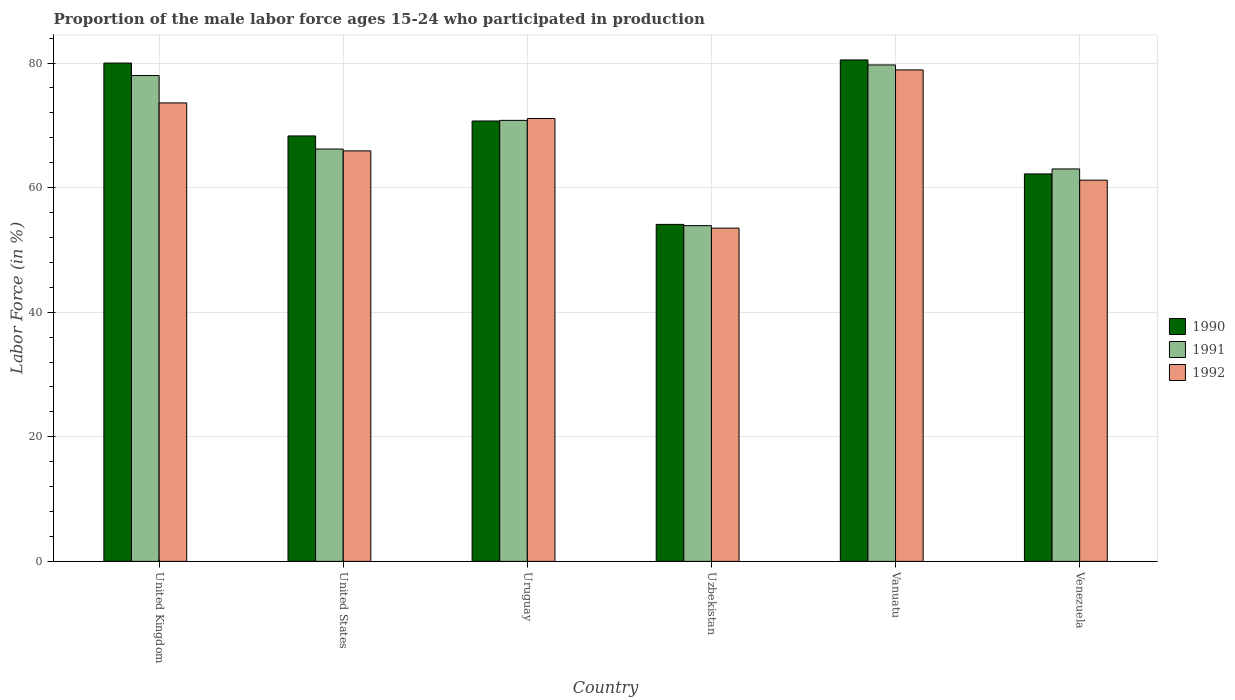How many groups of bars are there?
Ensure brevity in your answer.  6. Are the number of bars per tick equal to the number of legend labels?
Keep it short and to the point. Yes. How many bars are there on the 4th tick from the left?
Offer a terse response. 3. What is the label of the 2nd group of bars from the left?
Provide a short and direct response. United States. What is the proportion of the male labor force who participated in production in 1992 in Vanuatu?
Give a very brief answer. 78.9. Across all countries, what is the maximum proportion of the male labor force who participated in production in 1990?
Your response must be concise. 80.5. Across all countries, what is the minimum proportion of the male labor force who participated in production in 1992?
Offer a very short reply. 53.5. In which country was the proportion of the male labor force who participated in production in 1992 maximum?
Make the answer very short. Vanuatu. In which country was the proportion of the male labor force who participated in production in 1992 minimum?
Your response must be concise. Uzbekistan. What is the total proportion of the male labor force who participated in production in 1991 in the graph?
Provide a succinct answer. 411.6. What is the difference between the proportion of the male labor force who participated in production in 1991 in Uruguay and that in Venezuela?
Ensure brevity in your answer.  7.8. What is the difference between the proportion of the male labor force who participated in production in 1991 in United States and the proportion of the male labor force who participated in production in 1992 in United Kingdom?
Keep it short and to the point. -7.4. What is the average proportion of the male labor force who participated in production in 1991 per country?
Give a very brief answer. 68.6. What is the difference between the proportion of the male labor force who participated in production of/in 1992 and proportion of the male labor force who participated in production of/in 1990 in Uruguay?
Provide a short and direct response. 0.4. In how many countries, is the proportion of the male labor force who participated in production in 1992 greater than 64 %?
Ensure brevity in your answer.  4. What is the ratio of the proportion of the male labor force who participated in production in 1992 in United Kingdom to that in Venezuela?
Ensure brevity in your answer.  1.2. Is the proportion of the male labor force who participated in production in 1991 in Vanuatu less than that in Venezuela?
Keep it short and to the point. No. Is the difference between the proportion of the male labor force who participated in production in 1992 in United States and Uruguay greater than the difference between the proportion of the male labor force who participated in production in 1990 in United States and Uruguay?
Offer a terse response. No. What is the difference between the highest and the second highest proportion of the male labor force who participated in production in 1992?
Ensure brevity in your answer.  -5.3. What is the difference between the highest and the lowest proportion of the male labor force who participated in production in 1992?
Provide a succinct answer. 25.4. In how many countries, is the proportion of the male labor force who participated in production in 1992 greater than the average proportion of the male labor force who participated in production in 1992 taken over all countries?
Your response must be concise. 3. Is it the case that in every country, the sum of the proportion of the male labor force who participated in production in 1992 and proportion of the male labor force who participated in production in 1990 is greater than the proportion of the male labor force who participated in production in 1991?
Provide a succinct answer. Yes. Are all the bars in the graph horizontal?
Give a very brief answer. No. How many countries are there in the graph?
Your answer should be compact. 6. Are the values on the major ticks of Y-axis written in scientific E-notation?
Provide a succinct answer. No. Does the graph contain any zero values?
Your response must be concise. No. How many legend labels are there?
Your response must be concise. 3. What is the title of the graph?
Provide a short and direct response. Proportion of the male labor force ages 15-24 who participated in production. What is the Labor Force (in %) in 1990 in United Kingdom?
Offer a terse response. 80. What is the Labor Force (in %) of 1992 in United Kingdom?
Provide a succinct answer. 73.6. What is the Labor Force (in %) in 1990 in United States?
Offer a terse response. 68.3. What is the Labor Force (in %) of 1991 in United States?
Your response must be concise. 66.2. What is the Labor Force (in %) in 1992 in United States?
Provide a succinct answer. 65.9. What is the Labor Force (in %) of 1990 in Uruguay?
Your answer should be very brief. 70.7. What is the Labor Force (in %) in 1991 in Uruguay?
Your answer should be compact. 70.8. What is the Labor Force (in %) of 1992 in Uruguay?
Provide a short and direct response. 71.1. What is the Labor Force (in %) of 1990 in Uzbekistan?
Your response must be concise. 54.1. What is the Labor Force (in %) in 1991 in Uzbekistan?
Provide a short and direct response. 53.9. What is the Labor Force (in %) of 1992 in Uzbekistan?
Give a very brief answer. 53.5. What is the Labor Force (in %) in 1990 in Vanuatu?
Offer a very short reply. 80.5. What is the Labor Force (in %) in 1991 in Vanuatu?
Your response must be concise. 79.7. What is the Labor Force (in %) in 1992 in Vanuatu?
Your response must be concise. 78.9. What is the Labor Force (in %) of 1990 in Venezuela?
Provide a succinct answer. 62.2. What is the Labor Force (in %) of 1992 in Venezuela?
Give a very brief answer. 61.2. Across all countries, what is the maximum Labor Force (in %) in 1990?
Make the answer very short. 80.5. Across all countries, what is the maximum Labor Force (in %) of 1991?
Make the answer very short. 79.7. Across all countries, what is the maximum Labor Force (in %) in 1992?
Give a very brief answer. 78.9. Across all countries, what is the minimum Labor Force (in %) of 1990?
Offer a very short reply. 54.1. Across all countries, what is the minimum Labor Force (in %) in 1991?
Give a very brief answer. 53.9. Across all countries, what is the minimum Labor Force (in %) of 1992?
Your answer should be compact. 53.5. What is the total Labor Force (in %) of 1990 in the graph?
Give a very brief answer. 415.8. What is the total Labor Force (in %) of 1991 in the graph?
Your response must be concise. 411.6. What is the total Labor Force (in %) of 1992 in the graph?
Keep it short and to the point. 404.2. What is the difference between the Labor Force (in %) of 1992 in United Kingdom and that in United States?
Give a very brief answer. 7.7. What is the difference between the Labor Force (in %) in 1991 in United Kingdom and that in Uruguay?
Your answer should be compact. 7.2. What is the difference between the Labor Force (in %) of 1992 in United Kingdom and that in Uruguay?
Your response must be concise. 2.5. What is the difference between the Labor Force (in %) in 1990 in United Kingdom and that in Uzbekistan?
Make the answer very short. 25.9. What is the difference between the Labor Force (in %) of 1991 in United Kingdom and that in Uzbekistan?
Offer a terse response. 24.1. What is the difference between the Labor Force (in %) of 1992 in United Kingdom and that in Uzbekistan?
Offer a terse response. 20.1. What is the difference between the Labor Force (in %) in 1990 in United Kingdom and that in Vanuatu?
Your response must be concise. -0.5. What is the difference between the Labor Force (in %) of 1992 in United Kingdom and that in Vanuatu?
Offer a terse response. -5.3. What is the difference between the Labor Force (in %) of 1990 in United States and that in Uruguay?
Provide a short and direct response. -2.4. What is the difference between the Labor Force (in %) of 1991 in United States and that in Uruguay?
Your response must be concise. -4.6. What is the difference between the Labor Force (in %) of 1992 in United States and that in Uruguay?
Provide a succinct answer. -5.2. What is the difference between the Labor Force (in %) of 1991 in United States and that in Uzbekistan?
Give a very brief answer. 12.3. What is the difference between the Labor Force (in %) of 1992 in United States and that in Uzbekistan?
Keep it short and to the point. 12.4. What is the difference between the Labor Force (in %) in 1990 in United States and that in Vanuatu?
Give a very brief answer. -12.2. What is the difference between the Labor Force (in %) in 1991 in United States and that in Vanuatu?
Ensure brevity in your answer.  -13.5. What is the difference between the Labor Force (in %) of 1990 in United States and that in Venezuela?
Provide a succinct answer. 6.1. What is the difference between the Labor Force (in %) in 1991 in United States and that in Venezuela?
Give a very brief answer. 3.2. What is the difference between the Labor Force (in %) of 1992 in United States and that in Venezuela?
Offer a very short reply. 4.7. What is the difference between the Labor Force (in %) of 1990 in Uruguay and that in Uzbekistan?
Provide a short and direct response. 16.6. What is the difference between the Labor Force (in %) of 1991 in Uruguay and that in Uzbekistan?
Ensure brevity in your answer.  16.9. What is the difference between the Labor Force (in %) in 1991 in Uruguay and that in Venezuela?
Provide a short and direct response. 7.8. What is the difference between the Labor Force (in %) in 1992 in Uruguay and that in Venezuela?
Your answer should be very brief. 9.9. What is the difference between the Labor Force (in %) in 1990 in Uzbekistan and that in Vanuatu?
Your answer should be compact. -26.4. What is the difference between the Labor Force (in %) of 1991 in Uzbekistan and that in Vanuatu?
Offer a terse response. -25.8. What is the difference between the Labor Force (in %) of 1992 in Uzbekistan and that in Vanuatu?
Your answer should be compact. -25.4. What is the difference between the Labor Force (in %) in 1990 in Uzbekistan and that in Venezuela?
Keep it short and to the point. -8.1. What is the difference between the Labor Force (in %) in 1991 in Uzbekistan and that in Venezuela?
Your answer should be compact. -9.1. What is the difference between the Labor Force (in %) in 1990 in Vanuatu and that in Venezuela?
Your answer should be compact. 18.3. What is the difference between the Labor Force (in %) of 1990 in United Kingdom and the Labor Force (in %) of 1991 in United States?
Offer a very short reply. 13.8. What is the difference between the Labor Force (in %) of 1990 in United Kingdom and the Labor Force (in %) of 1992 in Uruguay?
Give a very brief answer. 8.9. What is the difference between the Labor Force (in %) in 1990 in United Kingdom and the Labor Force (in %) in 1991 in Uzbekistan?
Give a very brief answer. 26.1. What is the difference between the Labor Force (in %) in 1990 in United Kingdom and the Labor Force (in %) in 1992 in Uzbekistan?
Keep it short and to the point. 26.5. What is the difference between the Labor Force (in %) of 1990 in United Kingdom and the Labor Force (in %) of 1992 in Vanuatu?
Your answer should be compact. 1.1. What is the difference between the Labor Force (in %) in 1991 in United Kingdom and the Labor Force (in %) in 1992 in Vanuatu?
Ensure brevity in your answer.  -0.9. What is the difference between the Labor Force (in %) of 1991 in United Kingdom and the Labor Force (in %) of 1992 in Venezuela?
Make the answer very short. 16.8. What is the difference between the Labor Force (in %) of 1990 in United States and the Labor Force (in %) of 1991 in Uruguay?
Keep it short and to the point. -2.5. What is the difference between the Labor Force (in %) in 1990 in United States and the Labor Force (in %) in 1992 in Uzbekistan?
Your answer should be compact. 14.8. What is the difference between the Labor Force (in %) of 1990 in United States and the Labor Force (in %) of 1992 in Venezuela?
Your answer should be compact. 7.1. What is the difference between the Labor Force (in %) of 1991 in United States and the Labor Force (in %) of 1992 in Venezuela?
Give a very brief answer. 5. What is the difference between the Labor Force (in %) in 1991 in Uruguay and the Labor Force (in %) in 1992 in Uzbekistan?
Make the answer very short. 17.3. What is the difference between the Labor Force (in %) of 1991 in Uruguay and the Labor Force (in %) of 1992 in Vanuatu?
Offer a terse response. -8.1. What is the difference between the Labor Force (in %) in 1990 in Uruguay and the Labor Force (in %) in 1991 in Venezuela?
Give a very brief answer. 7.7. What is the difference between the Labor Force (in %) of 1990 in Uzbekistan and the Labor Force (in %) of 1991 in Vanuatu?
Provide a short and direct response. -25.6. What is the difference between the Labor Force (in %) in 1990 in Uzbekistan and the Labor Force (in %) in 1992 in Vanuatu?
Your answer should be very brief. -24.8. What is the difference between the Labor Force (in %) in 1990 in Uzbekistan and the Labor Force (in %) in 1992 in Venezuela?
Provide a short and direct response. -7.1. What is the difference between the Labor Force (in %) in 1991 in Uzbekistan and the Labor Force (in %) in 1992 in Venezuela?
Your answer should be compact. -7.3. What is the difference between the Labor Force (in %) of 1990 in Vanuatu and the Labor Force (in %) of 1992 in Venezuela?
Your answer should be very brief. 19.3. What is the difference between the Labor Force (in %) in 1991 in Vanuatu and the Labor Force (in %) in 1992 in Venezuela?
Your answer should be very brief. 18.5. What is the average Labor Force (in %) of 1990 per country?
Keep it short and to the point. 69.3. What is the average Labor Force (in %) of 1991 per country?
Your answer should be compact. 68.6. What is the average Labor Force (in %) of 1992 per country?
Ensure brevity in your answer.  67.37. What is the difference between the Labor Force (in %) in 1990 and Labor Force (in %) in 1991 in United Kingdom?
Give a very brief answer. 2. What is the difference between the Labor Force (in %) of 1990 and Labor Force (in %) of 1991 in United States?
Offer a terse response. 2.1. What is the difference between the Labor Force (in %) of 1990 and Labor Force (in %) of 1991 in Uruguay?
Make the answer very short. -0.1. What is the difference between the Labor Force (in %) in 1990 and Labor Force (in %) in 1992 in Uruguay?
Make the answer very short. -0.4. What is the difference between the Labor Force (in %) in 1991 and Labor Force (in %) in 1992 in Uzbekistan?
Give a very brief answer. 0.4. What is the difference between the Labor Force (in %) in 1990 and Labor Force (in %) in 1991 in Vanuatu?
Make the answer very short. 0.8. What is the difference between the Labor Force (in %) in 1991 and Labor Force (in %) in 1992 in Vanuatu?
Provide a succinct answer. 0.8. What is the difference between the Labor Force (in %) of 1990 and Labor Force (in %) of 1992 in Venezuela?
Provide a short and direct response. 1. What is the difference between the Labor Force (in %) of 1991 and Labor Force (in %) of 1992 in Venezuela?
Offer a very short reply. 1.8. What is the ratio of the Labor Force (in %) in 1990 in United Kingdom to that in United States?
Keep it short and to the point. 1.17. What is the ratio of the Labor Force (in %) of 1991 in United Kingdom to that in United States?
Provide a succinct answer. 1.18. What is the ratio of the Labor Force (in %) in 1992 in United Kingdom to that in United States?
Provide a succinct answer. 1.12. What is the ratio of the Labor Force (in %) in 1990 in United Kingdom to that in Uruguay?
Your response must be concise. 1.13. What is the ratio of the Labor Force (in %) in 1991 in United Kingdom to that in Uruguay?
Provide a short and direct response. 1.1. What is the ratio of the Labor Force (in %) in 1992 in United Kingdom to that in Uruguay?
Ensure brevity in your answer.  1.04. What is the ratio of the Labor Force (in %) of 1990 in United Kingdom to that in Uzbekistan?
Your answer should be compact. 1.48. What is the ratio of the Labor Force (in %) of 1991 in United Kingdom to that in Uzbekistan?
Provide a short and direct response. 1.45. What is the ratio of the Labor Force (in %) of 1992 in United Kingdom to that in Uzbekistan?
Ensure brevity in your answer.  1.38. What is the ratio of the Labor Force (in %) in 1991 in United Kingdom to that in Vanuatu?
Your answer should be compact. 0.98. What is the ratio of the Labor Force (in %) of 1992 in United Kingdom to that in Vanuatu?
Make the answer very short. 0.93. What is the ratio of the Labor Force (in %) in 1990 in United Kingdom to that in Venezuela?
Provide a short and direct response. 1.29. What is the ratio of the Labor Force (in %) in 1991 in United Kingdom to that in Venezuela?
Make the answer very short. 1.24. What is the ratio of the Labor Force (in %) in 1992 in United Kingdom to that in Venezuela?
Your answer should be compact. 1.2. What is the ratio of the Labor Force (in %) of 1990 in United States to that in Uruguay?
Ensure brevity in your answer.  0.97. What is the ratio of the Labor Force (in %) of 1991 in United States to that in Uruguay?
Keep it short and to the point. 0.94. What is the ratio of the Labor Force (in %) in 1992 in United States to that in Uruguay?
Offer a terse response. 0.93. What is the ratio of the Labor Force (in %) of 1990 in United States to that in Uzbekistan?
Make the answer very short. 1.26. What is the ratio of the Labor Force (in %) in 1991 in United States to that in Uzbekistan?
Keep it short and to the point. 1.23. What is the ratio of the Labor Force (in %) of 1992 in United States to that in Uzbekistan?
Your response must be concise. 1.23. What is the ratio of the Labor Force (in %) in 1990 in United States to that in Vanuatu?
Your answer should be very brief. 0.85. What is the ratio of the Labor Force (in %) in 1991 in United States to that in Vanuatu?
Offer a terse response. 0.83. What is the ratio of the Labor Force (in %) of 1992 in United States to that in Vanuatu?
Give a very brief answer. 0.84. What is the ratio of the Labor Force (in %) in 1990 in United States to that in Venezuela?
Offer a very short reply. 1.1. What is the ratio of the Labor Force (in %) in 1991 in United States to that in Venezuela?
Provide a short and direct response. 1.05. What is the ratio of the Labor Force (in %) in 1992 in United States to that in Venezuela?
Ensure brevity in your answer.  1.08. What is the ratio of the Labor Force (in %) of 1990 in Uruguay to that in Uzbekistan?
Offer a very short reply. 1.31. What is the ratio of the Labor Force (in %) of 1991 in Uruguay to that in Uzbekistan?
Ensure brevity in your answer.  1.31. What is the ratio of the Labor Force (in %) in 1992 in Uruguay to that in Uzbekistan?
Your response must be concise. 1.33. What is the ratio of the Labor Force (in %) of 1990 in Uruguay to that in Vanuatu?
Offer a very short reply. 0.88. What is the ratio of the Labor Force (in %) in 1991 in Uruguay to that in Vanuatu?
Provide a succinct answer. 0.89. What is the ratio of the Labor Force (in %) of 1992 in Uruguay to that in Vanuatu?
Provide a short and direct response. 0.9. What is the ratio of the Labor Force (in %) of 1990 in Uruguay to that in Venezuela?
Your answer should be very brief. 1.14. What is the ratio of the Labor Force (in %) in 1991 in Uruguay to that in Venezuela?
Your answer should be compact. 1.12. What is the ratio of the Labor Force (in %) of 1992 in Uruguay to that in Venezuela?
Offer a terse response. 1.16. What is the ratio of the Labor Force (in %) of 1990 in Uzbekistan to that in Vanuatu?
Offer a terse response. 0.67. What is the ratio of the Labor Force (in %) in 1991 in Uzbekistan to that in Vanuatu?
Provide a succinct answer. 0.68. What is the ratio of the Labor Force (in %) of 1992 in Uzbekistan to that in Vanuatu?
Offer a terse response. 0.68. What is the ratio of the Labor Force (in %) in 1990 in Uzbekistan to that in Venezuela?
Make the answer very short. 0.87. What is the ratio of the Labor Force (in %) in 1991 in Uzbekistan to that in Venezuela?
Give a very brief answer. 0.86. What is the ratio of the Labor Force (in %) of 1992 in Uzbekistan to that in Venezuela?
Your answer should be compact. 0.87. What is the ratio of the Labor Force (in %) in 1990 in Vanuatu to that in Venezuela?
Keep it short and to the point. 1.29. What is the ratio of the Labor Force (in %) of 1991 in Vanuatu to that in Venezuela?
Give a very brief answer. 1.27. What is the ratio of the Labor Force (in %) in 1992 in Vanuatu to that in Venezuela?
Provide a succinct answer. 1.29. What is the difference between the highest and the second highest Labor Force (in %) of 1990?
Your answer should be compact. 0.5. What is the difference between the highest and the lowest Labor Force (in %) of 1990?
Your response must be concise. 26.4. What is the difference between the highest and the lowest Labor Force (in %) of 1991?
Ensure brevity in your answer.  25.8. What is the difference between the highest and the lowest Labor Force (in %) of 1992?
Your answer should be very brief. 25.4. 